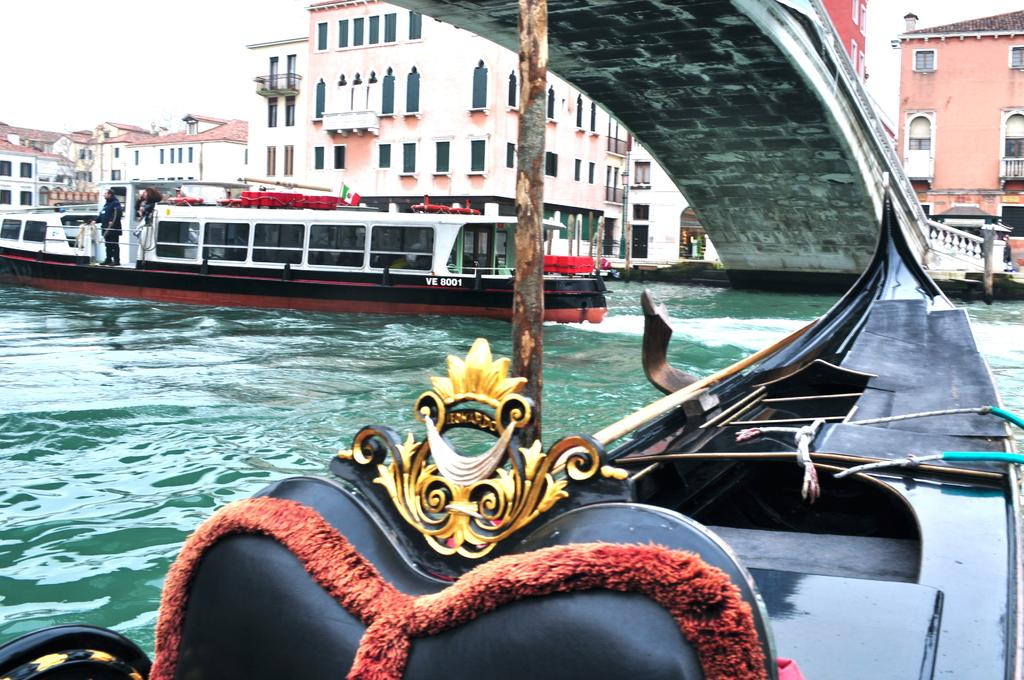What is floating on the water in the image? There are boats floating on the water in the image. What can be seen in the background of the image? There are buildings visible at the top of the image. What structure connects the two sides of the water in the image? There is a bridge in the top right of the image. What type of store can be seen in the image? There is no store present in the image; it features boats floating on water, buildings in the background, and a bridge. What position does the bridge hold in the image? The bridge is located in the top right of the image, connecting the two sides of the water. 